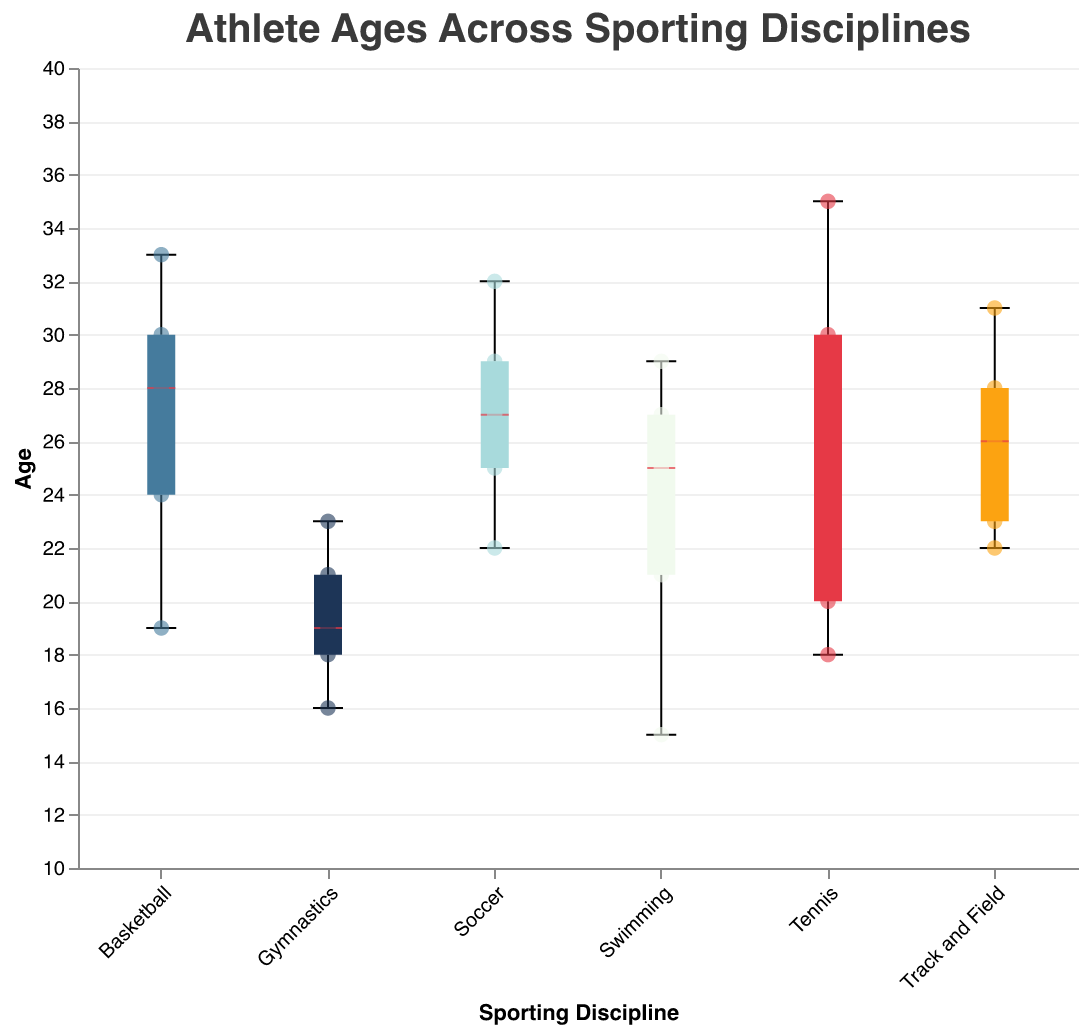What is the title of the figure? The title of the figure is usually displayed at the top. By looking at the top of the figure, you will see the title "Athlete Ages Across Sporting Disciplines" clearly written.
Answer: Athlete Ages Across Sporting Disciplines Which sport has the smallest age range? By observing the box plots, the length of the box and the whiskers represents the age range. The sport with the smallest range will have the shortest combination of the box and whiskers. For Gymnastics, the range is from 16 to 23 which appears to be the smallest range compared to other sports.
Answer: Gymnastics What are the median ages for Tennis and Soccer? The median is depicted by the line inside each box in the box plot for each sport. By looking at the line inside the Tennis and Soccer boxplots, the median for Tennis is around 26, and for Soccer, it is about 27.
Answer: Tennis: 26, Soccer: 27 Which sporting discipline has the athlete with the youngest age? By looking at the scatter points below the boxplots, we can see the youngest age for athletes. Swimming has the athlete with the youngest age, shown by a point at age 15.
Answer: Swimming How does the distribution of ages in Basketball compare to Track and Field? Basketball's boxplot has ages ranging from 19 to 33, while Track and Field ranges from 22 to 31. In Basketball, the median age is slightly lower, and the interquartile range is wider compared to Track and Field. This indicates Basketball has a broader spread of ages and a younger median compared to Track and Field.
Answer: Basketball has a broader age spread and a younger median What is the interquartile range for Basketball players? The interquartile range (IQR) is found between the 25th percentile and the 75th percentile of the box plot. For Basketball, it ranges from roughly 24 to 30. Subtracting, we get an IQR of 30 - 24 = 6.
Answer: 6 Which sporting discipline has the highest median age? To find which sport has the highest median age, look for the highest line inside the box plot. Tennis has the highest median age, which is around 26 or 27.
Answer: Tennis In Soccer, what is the experience level of the oldest athlete? By referring to the tooltip information visible for the scatter points, the oldest Soccer athlete is 32 years old, with an experience level of 12 years.
Answer: 12 years Compare the age distributions of Tennis and Swimming. Which has a wider spread and which has the older athletes on average? By observing the box plots and scatter points for Tennis and Swimming, Tennis has a wider range of ages from about 18 to 35. Swimming ranges from 15 to 29. The median age for Tennis (around 26) is higher compared to Swimming (around 25), suggesting older athletes on average.
Answer: Tennis has a wider spread and older athletes on average What is the difference between the oldest and the youngest athletes in Track and Field? The difference between the oldest (31 years) and the youngest (22 years) athletes in Track and Field is calculated by subtracting the youngest from the oldest: 31 - 22 = 9.
Answer: 9 